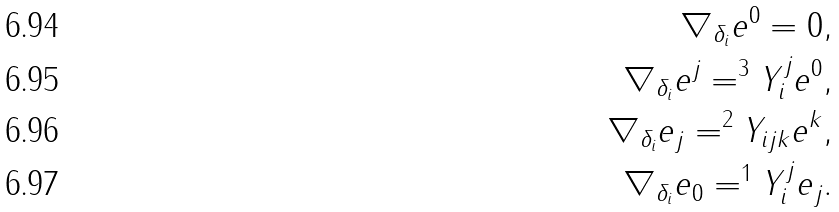Convert formula to latex. <formula><loc_0><loc_0><loc_500><loc_500>\nabla _ { \delta _ { i } } e ^ { 0 } = 0 , \\ \nabla _ { \delta _ { i } } e ^ { j } = ^ { 3 } Y _ { i } ^ { j } e ^ { 0 } , \\ \nabla _ { \delta _ { i } } e _ { j } = ^ { 2 } Y _ { i j k } e ^ { k } , \\ \nabla _ { \delta _ { i } } e _ { 0 } = ^ { 1 } Y _ { i } ^ { j } e _ { j } .</formula> 